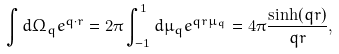<formula> <loc_0><loc_0><loc_500><loc_500>\int d \Omega _ { q } e ^ { { q } \cdot { r } } = 2 \pi \int _ { - 1 } ^ { 1 } d \mu _ { q } e ^ { q r \mu _ { q } } = 4 \pi \frac { \sinh ( q r ) } { q r } ,</formula> 